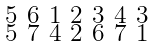Convert formula to latex. <formula><loc_0><loc_0><loc_500><loc_500>\begin{smallmatrix} 5 & 6 & 1 & 2 & 3 & 4 & 3 \\ 5 & 7 & 4 & 2 & 6 & 7 & 1 \end{smallmatrix}</formula> 